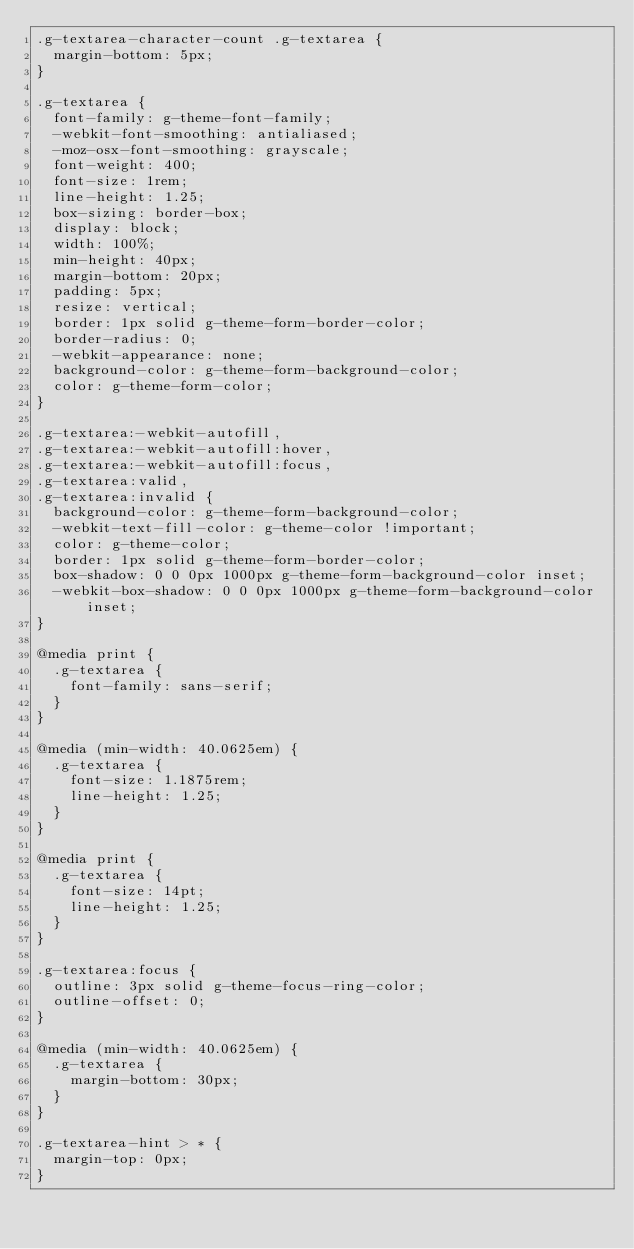<code> <loc_0><loc_0><loc_500><loc_500><_CSS_>.g-textarea-character-count .g-textarea {
  margin-bottom: 5px;
}

.g-textarea {
  font-family: g-theme-font-family;
  -webkit-font-smoothing: antialiased;
  -moz-osx-font-smoothing: grayscale;
  font-weight: 400;
  font-size: 1rem;
  line-height: 1.25;
  box-sizing: border-box;
  display: block;
  width: 100%;
  min-height: 40px;
  margin-bottom: 20px;
  padding: 5px;
  resize: vertical;
  border: 1px solid g-theme-form-border-color;
  border-radius: 0;
  -webkit-appearance: none;
  background-color: g-theme-form-background-color;
  color: g-theme-form-color;
}

.g-textarea:-webkit-autofill,
.g-textarea:-webkit-autofill:hover,
.g-textarea:-webkit-autofill:focus,
.g-textarea:valid,
.g-textarea:invalid {
  background-color: g-theme-form-background-color;
  -webkit-text-fill-color: g-theme-color !important;
  color: g-theme-color;
  border: 1px solid g-theme-form-border-color;
  box-shadow: 0 0 0px 1000px g-theme-form-background-color inset;
  -webkit-box-shadow: 0 0 0px 1000px g-theme-form-background-color inset;
}

@media print {
  .g-textarea {
    font-family: sans-serif;
  }
}

@media (min-width: 40.0625em) {
  .g-textarea {
    font-size: 1.1875rem;
    line-height: 1.25;
  }
}

@media print {
  .g-textarea {
    font-size: 14pt;
    line-height: 1.25;
  }
}

.g-textarea:focus {
  outline: 3px solid g-theme-focus-ring-color;
  outline-offset: 0;
}

@media (min-width: 40.0625em) {
  .g-textarea {
    margin-bottom: 30px;
  }
}

.g-textarea-hint > * {
  margin-top: 0px;
}
</code> 